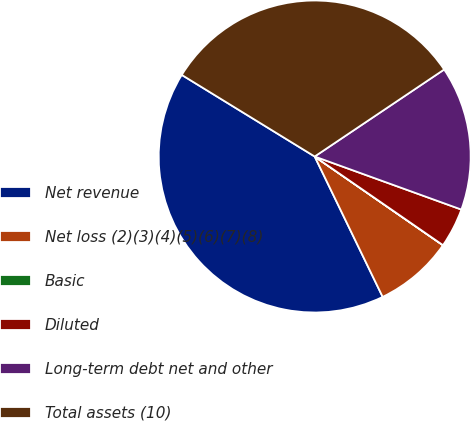<chart> <loc_0><loc_0><loc_500><loc_500><pie_chart><fcel>Net revenue<fcel>Net loss (2)(3)(4)(5)(6)(7)(8)<fcel>Basic<fcel>Diluted<fcel>Long-term debt net and other<fcel>Total assets (10)<nl><fcel>40.94%<fcel>8.19%<fcel>0.01%<fcel>4.1%<fcel>14.94%<fcel>31.82%<nl></chart> 